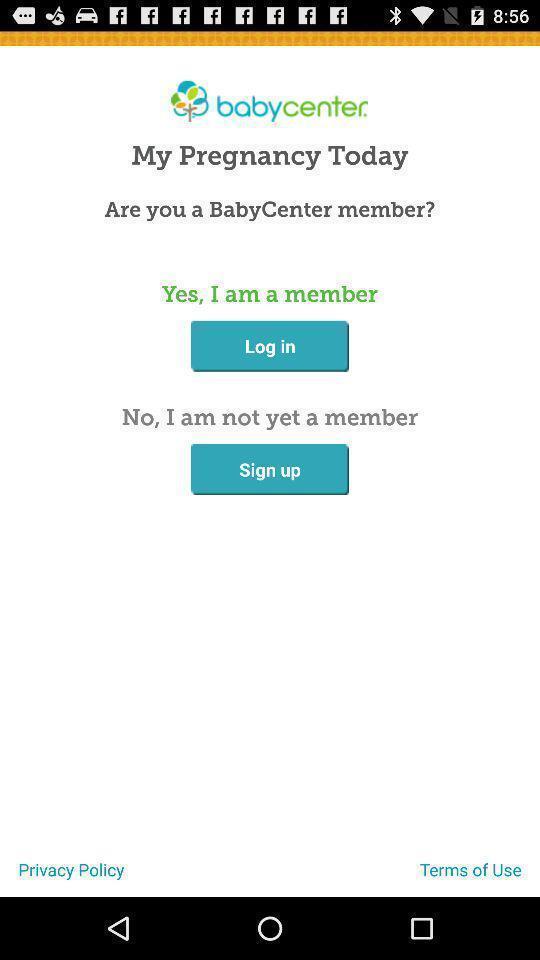Summarize the main components in this picture. Welcome page of health application. 